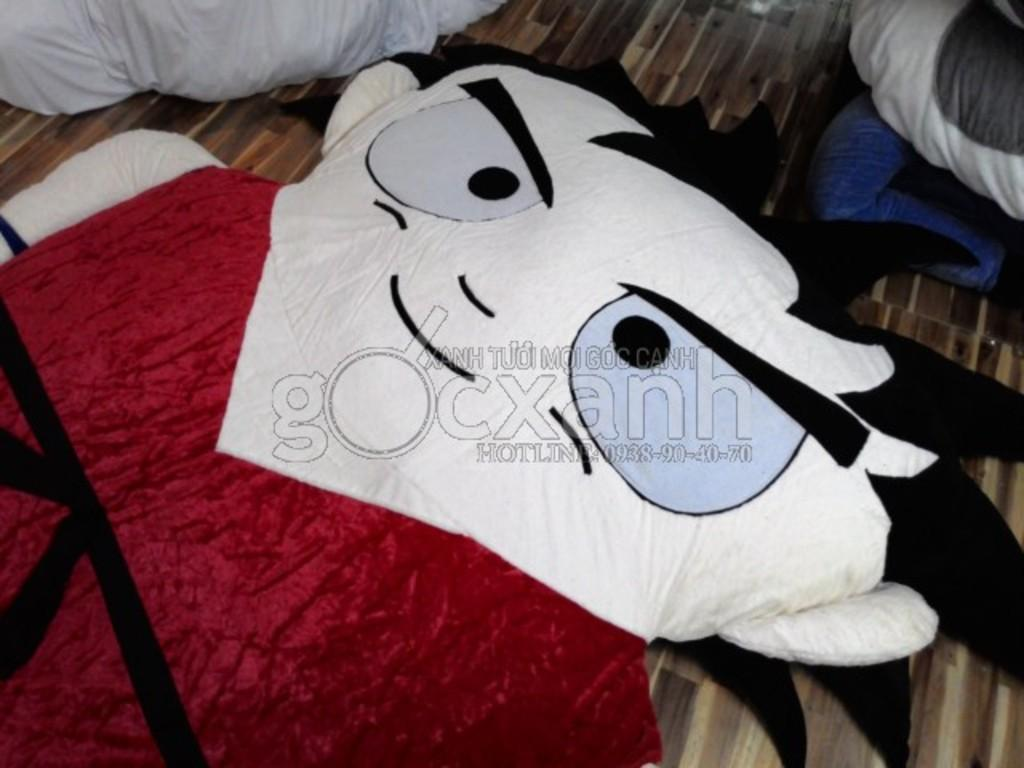What is placed on the floor in the image? There is a toy of a person on the floor. Can you describe the objects at the top of the image? Unfortunately, the facts provided do not give any information about the objects at the top of the image. What is the watermark in the center of the image? The facts provided do not give any information about the watermark in the center of the image. What type of neck accessory is the coach wearing in the image? There is no coach or neck accessory present in the image. 